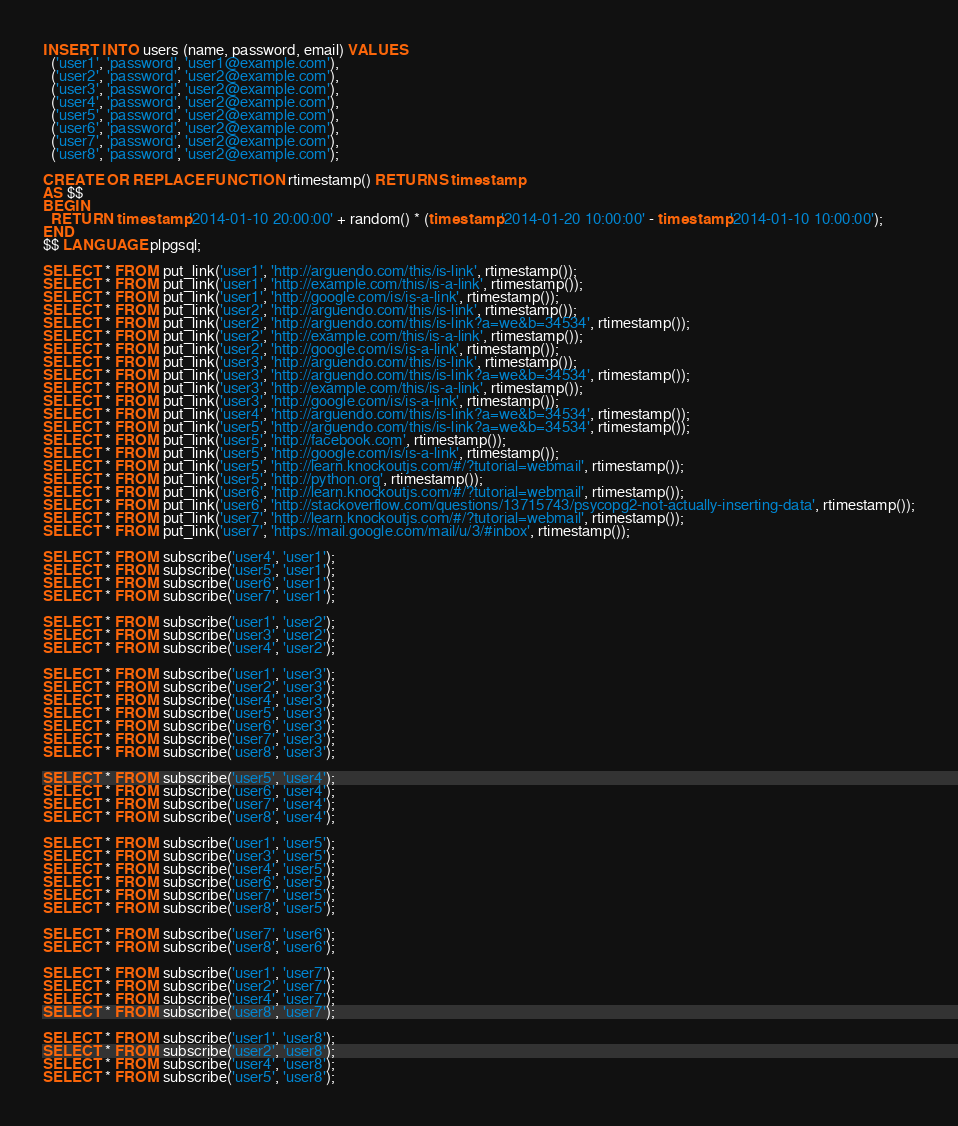<code> <loc_0><loc_0><loc_500><loc_500><_SQL_>INSERT INTO users (name, password, email) VALUES
  ('user1', 'password', 'user1@example.com'),
  ('user2', 'password', 'user2@example.com'),
  ('user3', 'password', 'user2@example.com'),
  ('user4', 'password', 'user2@example.com'),
  ('user5', 'password', 'user2@example.com'),
  ('user6', 'password', 'user2@example.com'),
  ('user7', 'password', 'user2@example.com'),
  ('user8', 'password', 'user2@example.com');

CREATE OR REPLACE FUNCTION rtimestamp() RETURNS timestamp
AS $$
BEGIN
  RETURN timestamp '2014-01-10 20:00:00' + random() * (timestamp '2014-01-20 10:00:00' - timestamp '2014-01-10 10:00:00');
END
$$ LANGUAGE plpgsql;

SELECT * FROM put_link('user1', 'http://arguendo.com/this/is-link', rtimestamp());
SELECT * FROM put_link('user1', 'http://example.com/this/is-a-link', rtimestamp());
SELECT * FROM put_link('user1', 'http://google.com/is/is-a-link', rtimestamp());
SELECT * FROM put_link('user2', 'http://arguendo.com/this/is-link', rtimestamp());
SELECT * FROM put_link('user2', 'http://arguendo.com/this/is-link?a=we&b=34534', rtimestamp());
SELECT * FROM put_link('user2', 'http://example.com/this/is-a-link', rtimestamp());
SELECT * FROM put_link('user2', 'http://google.com/is/is-a-link', rtimestamp());
SELECT * FROM put_link('user3', 'http://arguendo.com/this/is-link', rtimestamp());
SELECT * FROM put_link('user3', 'http://arguendo.com/this/is-link?a=we&b=34534', rtimestamp());
SELECT * FROM put_link('user3', 'http://example.com/this/is-a-link', rtimestamp());
SELECT * FROM put_link('user3', 'http://google.com/is/is-a-link', rtimestamp());
SELECT * FROM put_link('user4', 'http://arguendo.com/this/is-link?a=we&b=34534', rtimestamp());
SELECT * FROM put_link('user5', 'http://arguendo.com/this/is-link?a=we&b=34534', rtimestamp());
SELECT * FROM put_link('user5', 'http://facebook.com', rtimestamp());
SELECT * FROM put_link('user5', 'http://google.com/is/is-a-link', rtimestamp());
SELECT * FROM put_link('user5', 'http://learn.knockoutjs.com/#/?tutorial=webmail', rtimestamp());
SELECT * FROM put_link('user5', 'http://python.org', rtimestamp());
SELECT * FROM put_link('user6', 'http://learn.knockoutjs.com/#/?tutorial=webmail', rtimestamp());
SELECT * FROM put_link('user6', 'http://stackoverflow.com/questions/13715743/psycopg2-not-actually-inserting-data', rtimestamp());
SELECT * FROM put_link('user7', 'http://learn.knockoutjs.com/#/?tutorial=webmail', rtimestamp());
SELECT * FROM put_link('user7', 'https://mail.google.com/mail/u/3/#inbox', rtimestamp());

SELECT * FROM subscribe('user4', 'user1');
SELECT * FROM subscribe('user5', 'user1');
SELECT * FROM subscribe('user6', 'user1');
SELECT * FROM subscribe('user7', 'user1');

SELECT * FROM subscribe('user1', 'user2');
SELECT * FROM subscribe('user3', 'user2');
SELECT * FROM subscribe('user4', 'user2');

SELECT * FROM subscribe('user1', 'user3');
SELECT * FROM subscribe('user2', 'user3');
SELECT * FROM subscribe('user4', 'user3');
SELECT * FROM subscribe('user5', 'user3');
SELECT * FROM subscribe('user6', 'user3');
SELECT * FROM subscribe('user7', 'user3');
SELECT * FROM subscribe('user8', 'user3');

SELECT * FROM subscribe('user5', 'user4');
SELECT * FROM subscribe('user6', 'user4');
SELECT * FROM subscribe('user7', 'user4');
SELECT * FROM subscribe('user8', 'user4');

SELECT * FROM subscribe('user1', 'user5');
SELECT * FROM subscribe('user3', 'user5');
SELECT * FROM subscribe('user4', 'user5');
SELECT * FROM subscribe('user6', 'user5');
SELECT * FROM subscribe('user7', 'user5');
SELECT * FROM subscribe('user8', 'user5');

SELECT * FROM subscribe('user7', 'user6');
SELECT * FROM subscribe('user8', 'user6');

SELECT * FROM subscribe('user1', 'user7');
SELECT * FROM subscribe('user2', 'user7');
SELECT * FROM subscribe('user4', 'user7');
SELECT * FROM subscribe('user8', 'user7');

SELECT * FROM subscribe('user1', 'user8');
SELECT * FROM subscribe('user2', 'user8');
SELECT * FROM subscribe('user4', 'user8');
SELECT * FROM subscribe('user5', 'user8');

</code> 